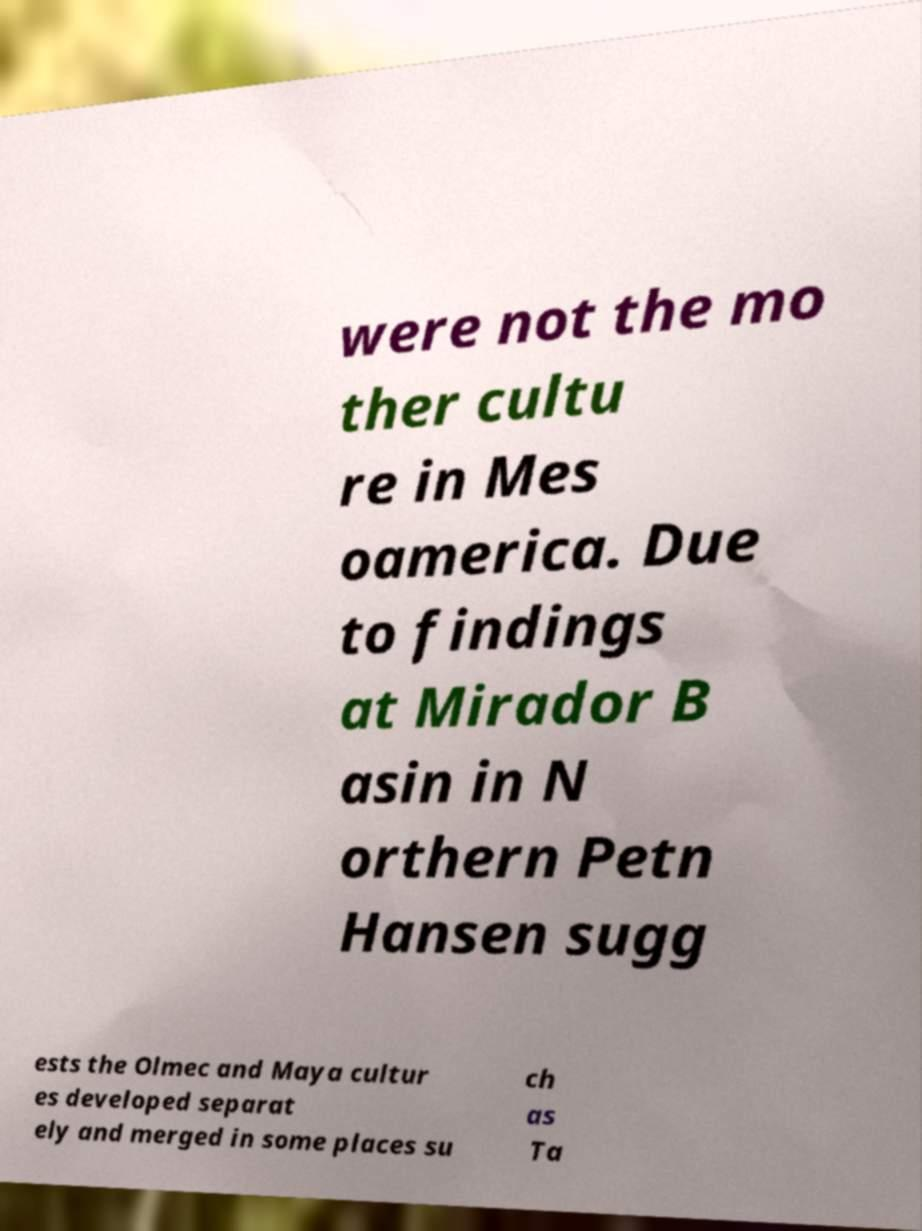Please read and relay the text visible in this image. What does it say? were not the mo ther cultu re in Mes oamerica. Due to findings at Mirador B asin in N orthern Petn Hansen sugg ests the Olmec and Maya cultur es developed separat ely and merged in some places su ch as Ta 